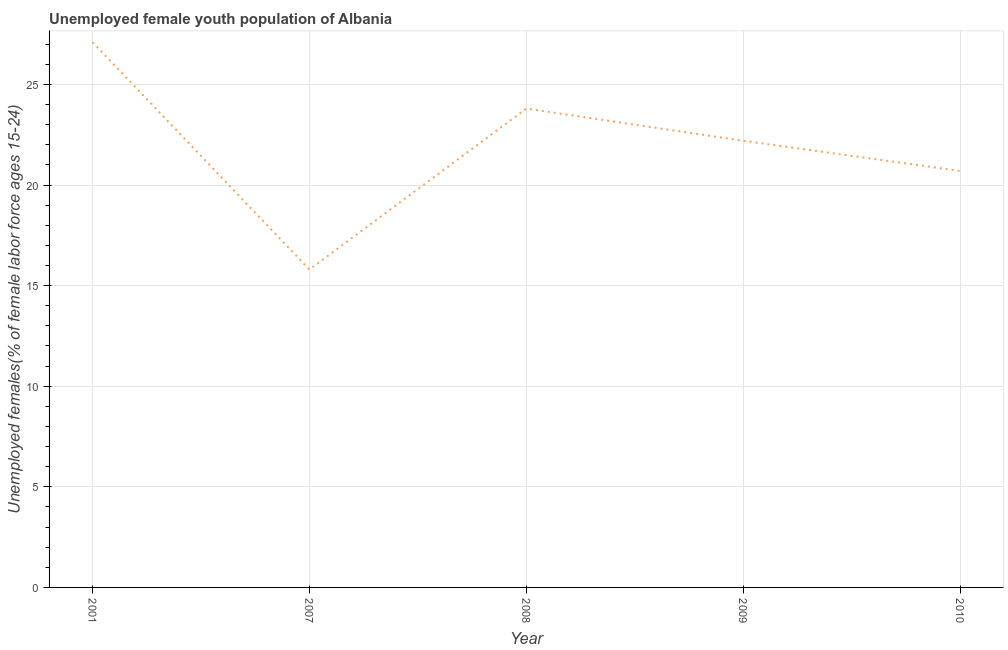What is the unemployed female youth in 2007?
Ensure brevity in your answer.  15.8. Across all years, what is the maximum unemployed female youth?
Provide a short and direct response. 27.1. Across all years, what is the minimum unemployed female youth?
Your answer should be very brief. 15.8. In which year was the unemployed female youth maximum?
Your response must be concise. 2001. What is the sum of the unemployed female youth?
Ensure brevity in your answer.  109.6. What is the difference between the unemployed female youth in 2008 and 2010?
Offer a very short reply. 3.1. What is the average unemployed female youth per year?
Give a very brief answer. 21.92. What is the median unemployed female youth?
Ensure brevity in your answer.  22.2. Do a majority of the years between 2001 and 2010 (inclusive) have unemployed female youth greater than 7 %?
Give a very brief answer. Yes. What is the ratio of the unemployed female youth in 2008 to that in 2009?
Offer a terse response. 1.07. Is the difference between the unemployed female youth in 2009 and 2010 greater than the difference between any two years?
Your answer should be very brief. No. What is the difference between the highest and the second highest unemployed female youth?
Give a very brief answer. 3.3. What is the difference between the highest and the lowest unemployed female youth?
Offer a terse response. 11.3. How many lines are there?
Your answer should be very brief. 1. What is the difference between two consecutive major ticks on the Y-axis?
Your answer should be compact. 5. Does the graph contain any zero values?
Make the answer very short. No. Does the graph contain grids?
Ensure brevity in your answer.  Yes. What is the title of the graph?
Keep it short and to the point. Unemployed female youth population of Albania. What is the label or title of the Y-axis?
Ensure brevity in your answer.  Unemployed females(% of female labor force ages 15-24). What is the Unemployed females(% of female labor force ages 15-24) in 2001?
Ensure brevity in your answer.  27.1. What is the Unemployed females(% of female labor force ages 15-24) in 2007?
Your answer should be very brief. 15.8. What is the Unemployed females(% of female labor force ages 15-24) in 2008?
Your answer should be compact. 23.8. What is the Unemployed females(% of female labor force ages 15-24) of 2009?
Your answer should be compact. 22.2. What is the Unemployed females(% of female labor force ages 15-24) of 2010?
Ensure brevity in your answer.  20.7. What is the difference between the Unemployed females(% of female labor force ages 15-24) in 2001 and 2008?
Make the answer very short. 3.3. What is the difference between the Unemployed females(% of female labor force ages 15-24) in 2001 and 2010?
Keep it short and to the point. 6.4. What is the difference between the Unemployed females(% of female labor force ages 15-24) in 2007 and 2008?
Give a very brief answer. -8. What is the difference between the Unemployed females(% of female labor force ages 15-24) in 2007 and 2009?
Your answer should be very brief. -6.4. What is the difference between the Unemployed females(% of female labor force ages 15-24) in 2007 and 2010?
Keep it short and to the point. -4.9. What is the difference between the Unemployed females(% of female labor force ages 15-24) in 2008 and 2009?
Make the answer very short. 1.6. What is the difference between the Unemployed females(% of female labor force ages 15-24) in 2009 and 2010?
Offer a very short reply. 1.5. What is the ratio of the Unemployed females(% of female labor force ages 15-24) in 2001 to that in 2007?
Offer a terse response. 1.72. What is the ratio of the Unemployed females(% of female labor force ages 15-24) in 2001 to that in 2008?
Offer a terse response. 1.14. What is the ratio of the Unemployed females(% of female labor force ages 15-24) in 2001 to that in 2009?
Provide a short and direct response. 1.22. What is the ratio of the Unemployed females(% of female labor force ages 15-24) in 2001 to that in 2010?
Give a very brief answer. 1.31. What is the ratio of the Unemployed females(% of female labor force ages 15-24) in 2007 to that in 2008?
Give a very brief answer. 0.66. What is the ratio of the Unemployed females(% of female labor force ages 15-24) in 2007 to that in 2009?
Provide a short and direct response. 0.71. What is the ratio of the Unemployed females(% of female labor force ages 15-24) in 2007 to that in 2010?
Give a very brief answer. 0.76. What is the ratio of the Unemployed females(% of female labor force ages 15-24) in 2008 to that in 2009?
Ensure brevity in your answer.  1.07. What is the ratio of the Unemployed females(% of female labor force ages 15-24) in 2008 to that in 2010?
Give a very brief answer. 1.15. What is the ratio of the Unemployed females(% of female labor force ages 15-24) in 2009 to that in 2010?
Your answer should be compact. 1.07. 